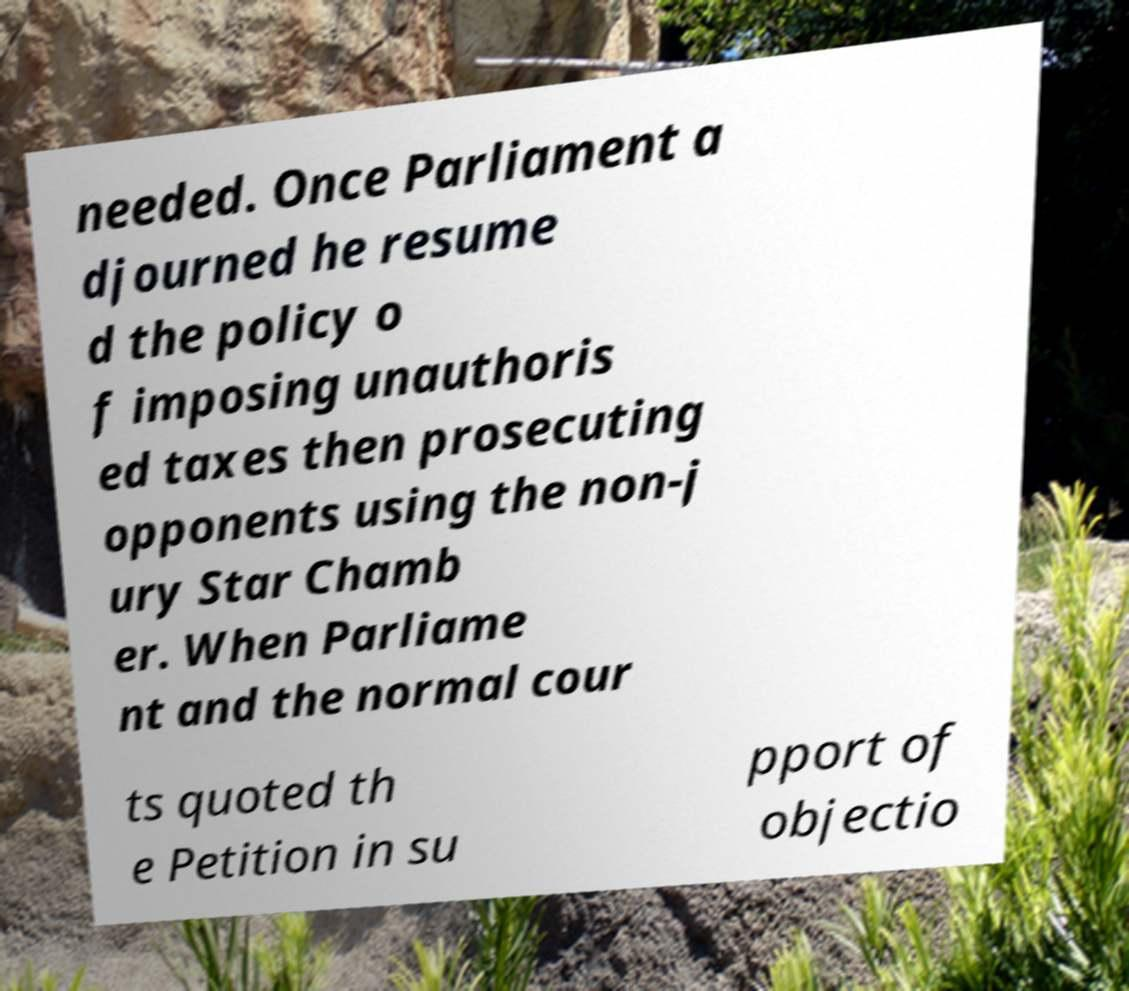I need the written content from this picture converted into text. Can you do that? needed. Once Parliament a djourned he resume d the policy o f imposing unauthoris ed taxes then prosecuting opponents using the non-j ury Star Chamb er. When Parliame nt and the normal cour ts quoted th e Petition in su pport of objectio 